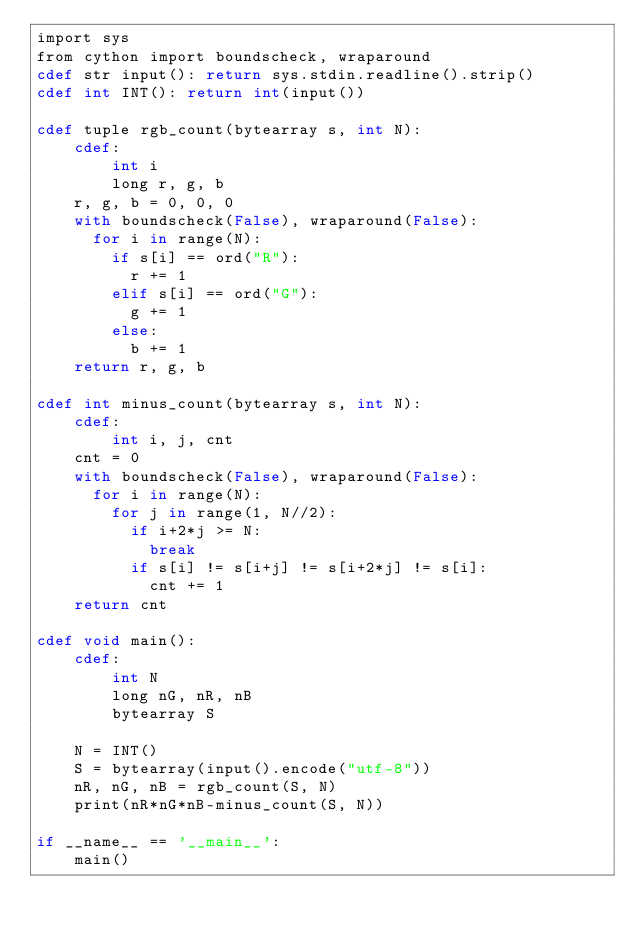Convert code to text. <code><loc_0><loc_0><loc_500><loc_500><_Cython_>import sys
from cython import boundscheck, wraparound
cdef str input(): return sys.stdin.readline().strip()
cdef int INT(): return int(input())

cdef tuple rgb_count(bytearray s, int N):
    cdef:
        int i
        long r, g, b
    r, g, b = 0, 0, 0
    with boundscheck(False), wraparound(False):
      for i in range(N):
        if s[i] == ord("R"):
          r += 1
        elif s[i] == ord("G"):
          g += 1
        else:
          b += 1
    return r, g, b

cdef int minus_count(bytearray s, int N):
    cdef:
        int i, j, cnt
    cnt = 0
    with boundscheck(False), wraparound(False):
      for i in range(N):
        for j in range(1, N//2):
          if i+2*j >= N:
            break
          if s[i] != s[i+j] != s[i+2*j] != s[i]:
            cnt += 1
    return cnt

cdef void main():
    cdef:
        int N
        long nG, nR, nB
        bytearray S

    N = INT()
    S = bytearray(input().encode("utf-8"))
    nR, nG, nB = rgb_count(S, N)
    print(nR*nG*nB-minus_count(S, N))
 
if __name__ == '__main__':
    main()
</code> 